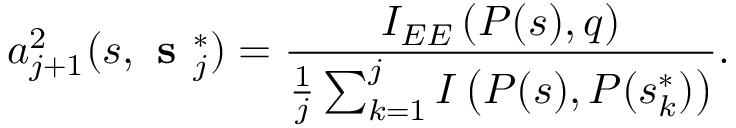<formula> <loc_0><loc_0><loc_500><loc_500>a _ { j + 1 } ^ { 2 } ( s , s _ { j } ^ { * } ) = \frac { I _ { E E } \left ( P ( s ) , q \right ) } { \frac { 1 } { j } \sum _ { k = 1 } ^ { j } I \left ( P ( s ) , P ( s _ { k } ^ { * } ) \right ) } .</formula> 